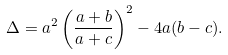<formula> <loc_0><loc_0><loc_500><loc_500>\Delta = a ^ { 2 } \left ( \frac { a + b } { a + c } \right ) ^ { 2 } - 4 a ( b - c ) .</formula> 